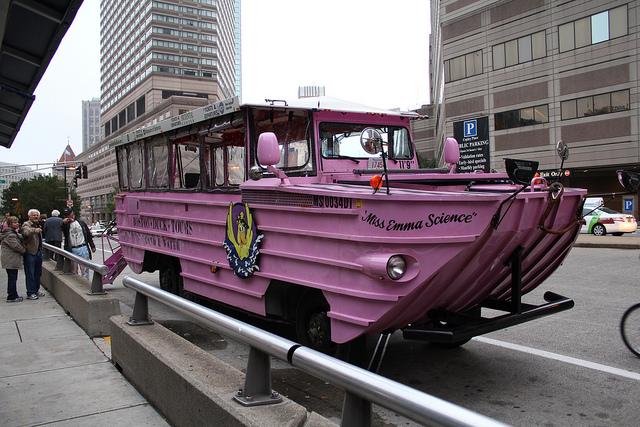Does the car look like a boat?
Quick response, please. Yes. Is this in the city?
Keep it brief. Yes. What color is this vehicle?
Be succinct. Purple. 